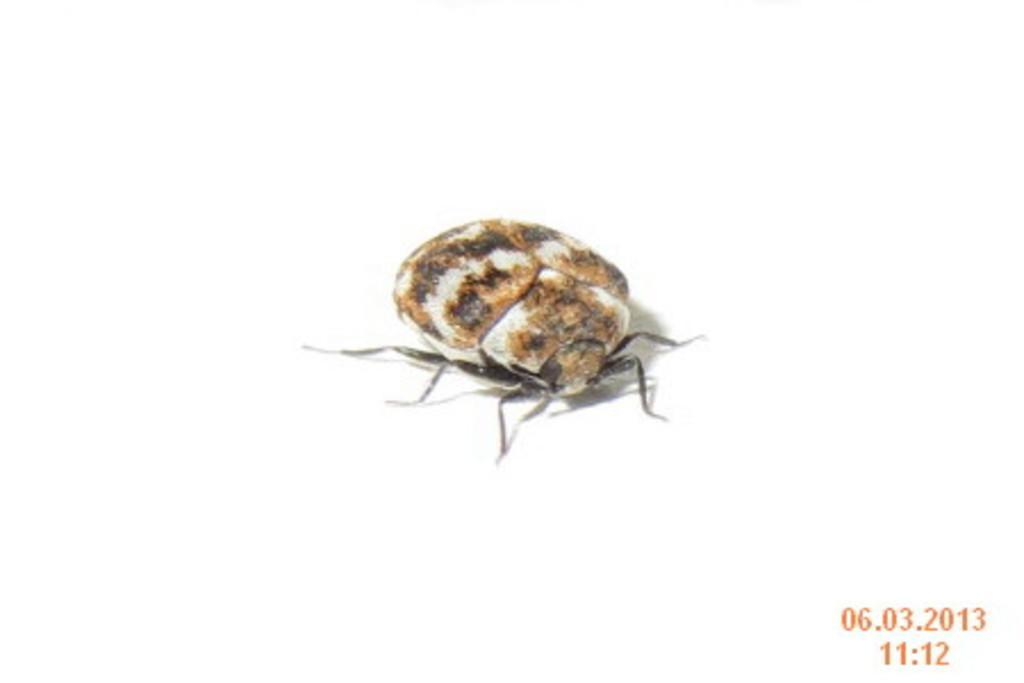What is the main subject in the center of the image? There is an insect in the center of the image. What color is the background of the image? The background of the image is white. Where can the date and time be found in the image? The date and time are visible on the right side of the image. How many beads are hanging from the doll's arm in the image? There is no doll or beads present in the image; it features an insect and a white background. 